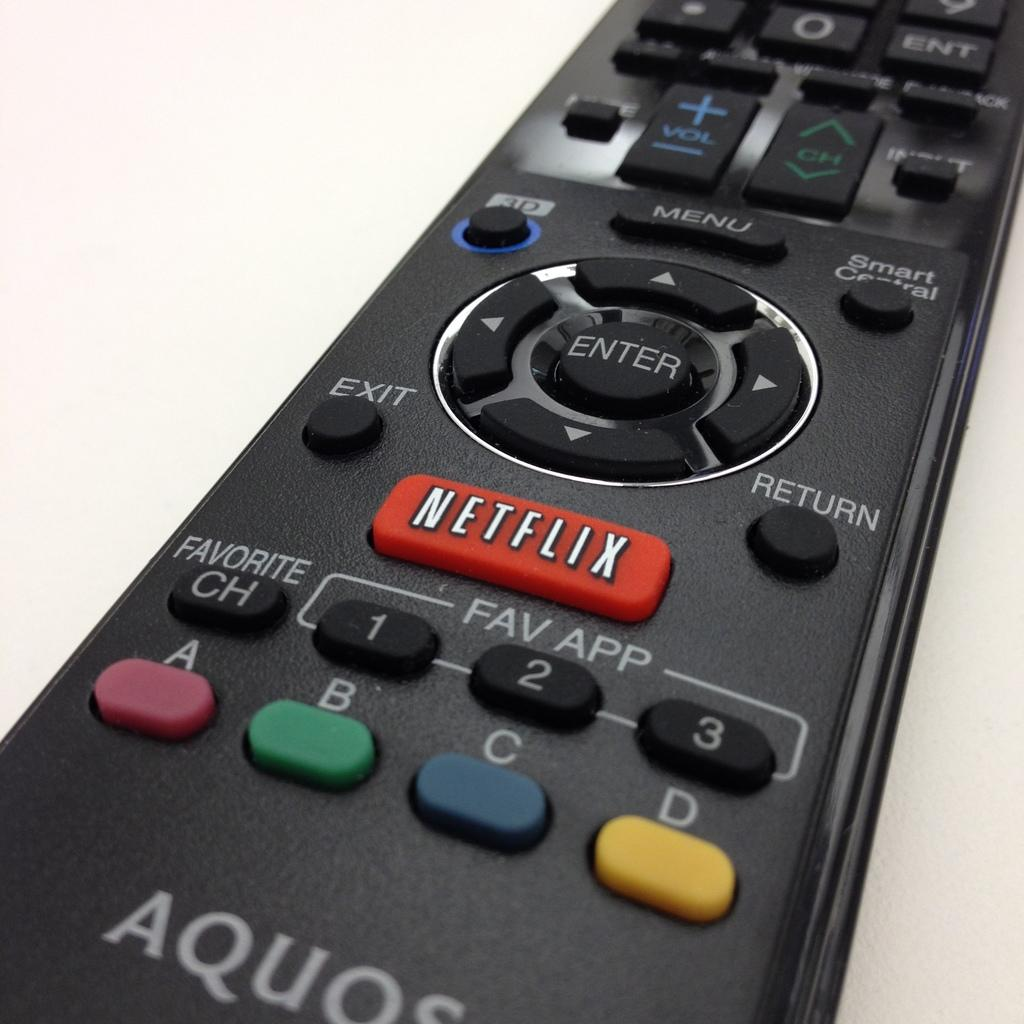What object can be seen on the surface in the image? There is a remote on the surface. What might the remote be used for? The remote could be used to control electronic devices, such as a television or sound system. What type of surface is the remote placed on? The specific type of surface is not mentioned, but it is clear that the remote is placed on a flat surface. What type of toys can be seen in the image? There are no toys present in the image; it only features a remote on a surface. 